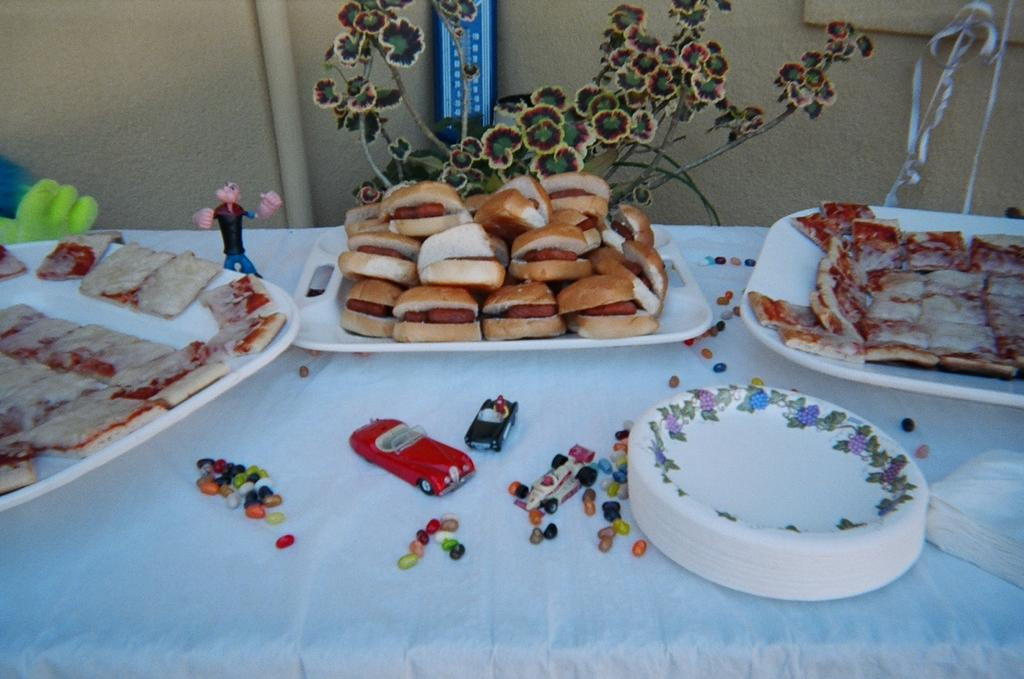What can be found on the table in the image? There are trays with food items, plates, tissues, and toys on the table. What is the purpose of the tissues on the table? The tissues on the table might be used for cleaning or wiping. What is visible on the wall behind the table? There is a pipe and a blue color object on the wall. What type of company is being discussed at the table in the image? There is no indication of a company or any discussion taking place in the image. What type of flesh can be seen on the plates in the image? There is no flesh visible on the plates in the image; only food items are present. 